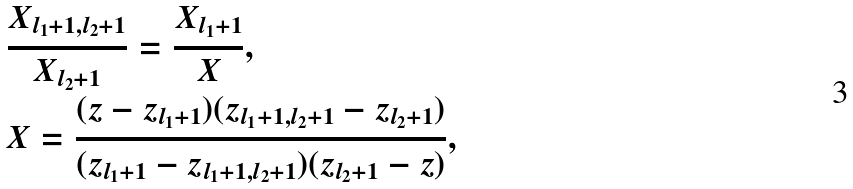Convert formula to latex. <formula><loc_0><loc_0><loc_500><loc_500>& \frac { X _ { l _ { 1 } + 1 , l _ { 2 } + 1 } } { X _ { l _ { 2 } + 1 } } = \frac { X _ { l _ { 1 } + 1 } } { X } , \\ & X = \frac { ( z - z _ { l _ { 1 } + 1 } ) ( z _ { l _ { 1 } + 1 , l _ { 2 } + 1 } - z _ { l _ { 2 } + 1 } ) } { ( z _ { l _ { 1 } + 1 } - z _ { l _ { 1 } + 1 , l _ { 2 } + 1 } ) ( z _ { l _ { 2 } + 1 } - z ) } ,</formula> 